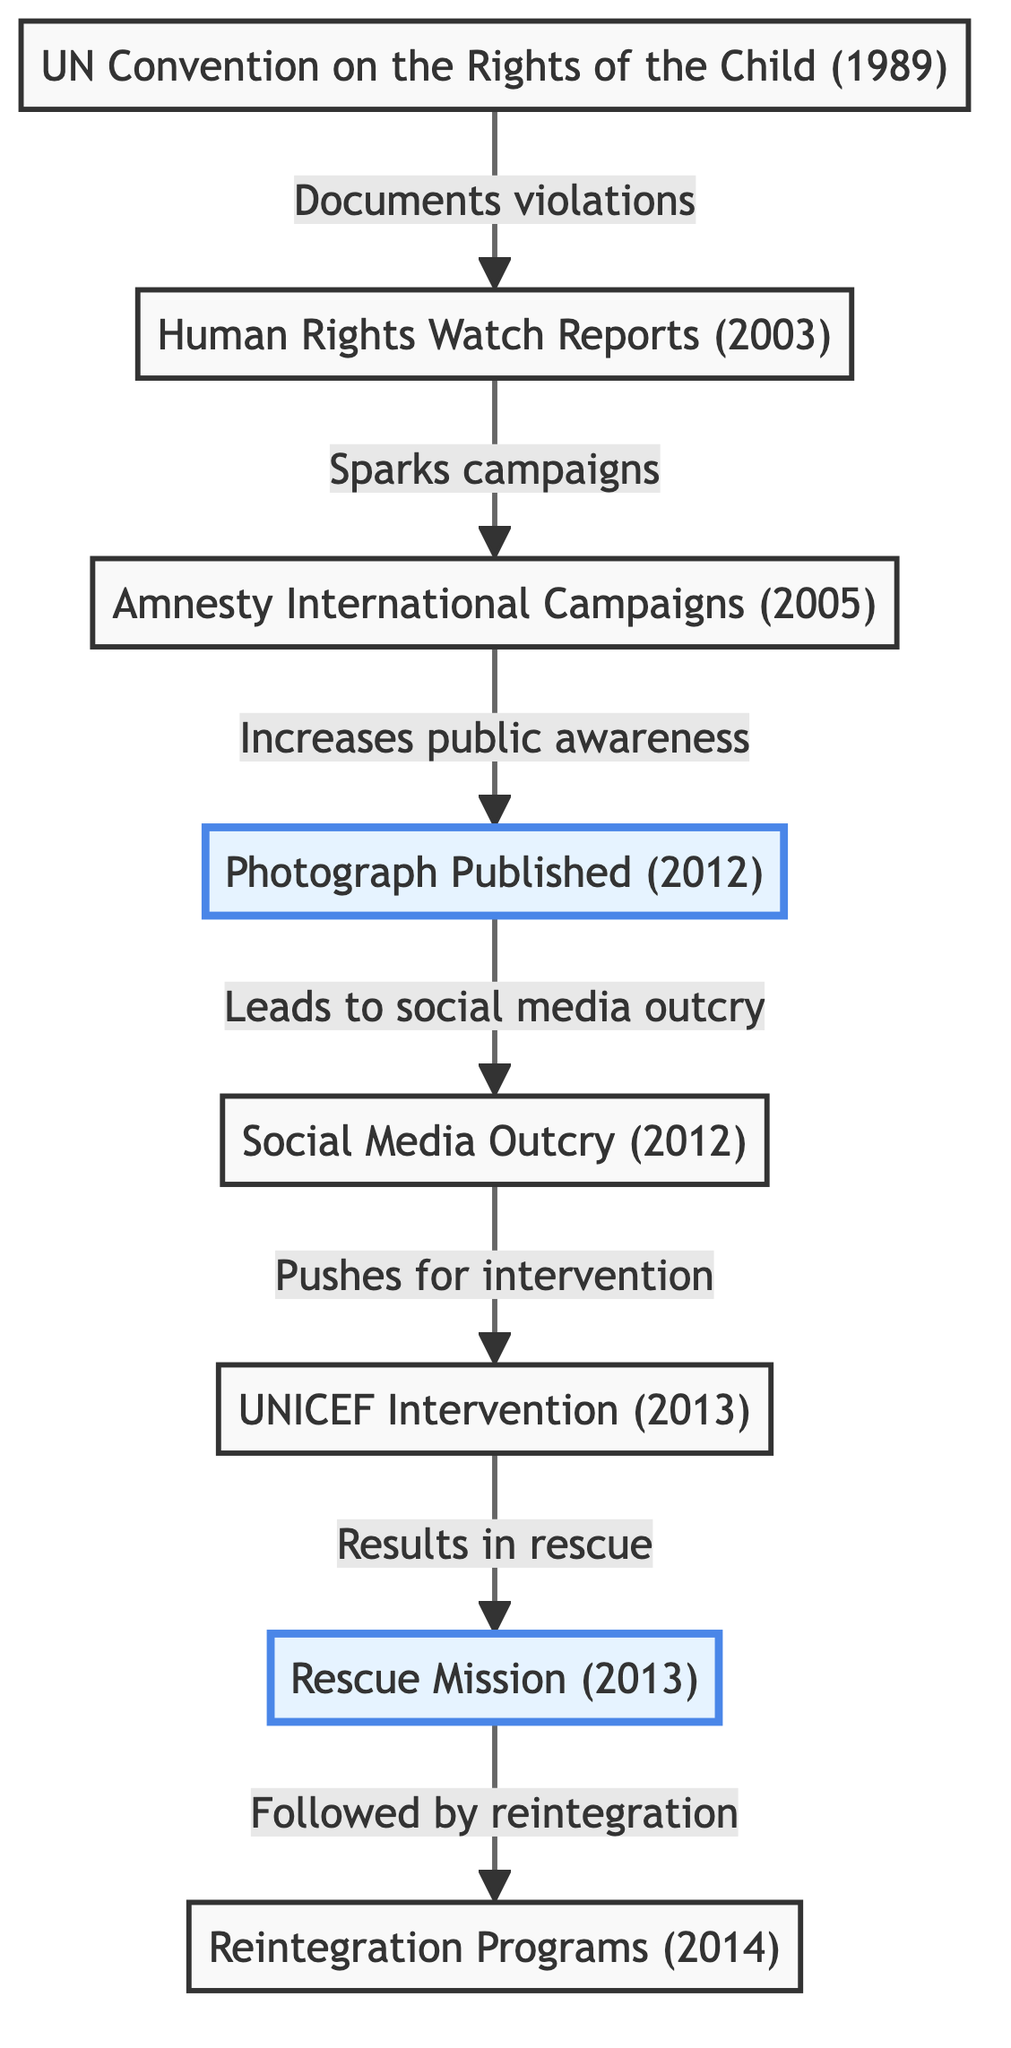What year was the UN Convention on the Rights of the Child established? The first node in the diagram shows that the UN Convention on the Rights of the Child was established in 1989.
Answer: 1989 Which event led to the UNICEF Intervention? The flow from the Social Media Outcry in 2012 to the UNICEF Intervention in 2013 indicates that the outcry pushed for intervention, leading to this event.
Answer: Social Media Outcry How many nodes are connected to the Photograph Published event? The Photograph Published node has one outgoing connection to Social Media Outcry and one incoming connection from Human Rights Watch Reports, indicating it is connected to two nodes.
Answer: 2 What organization initiated campaigns in 2005? The diagram directly states that Amnesty International initiated campaigns in 2005, as identified in the node.
Answer: Amnesty International What was the outcome of the UNICEF Intervention? The arrow from the UNICEF Intervention in 2013 to the Rescue Mission in 2013 indicates that the intervention resulted in a rescue mission.
Answer: Rescue Mission What type of document is represented by the first node? The first node refers to a "Convention," indicating it is a formal document regarding children's rights.
Answer: Convention How did the Human Rights Watch Reports affect public awareness? The diagram shows that Human Rights Watch Reports sparked campaigns, which subsequently increased public awareness through the connection to the Photograph Published.
Answer: Increased public awareness What year did the Rescue Mission take place? The node representing the Rescue Mission clearly indicates it happened in the year 2013, as shown in the timeline.
Answer: 2013 What is the final step after the Rescue Mission? The final node in the timeline denotes that the last step after the Rescue Mission is the implementation of Reintegration Programs in 2014.
Answer: Reintegration Programs 